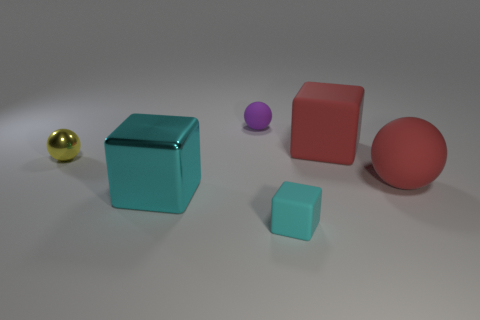Add 4 tiny purple matte objects. How many objects exist? 10 Add 1 big cubes. How many big cubes are left? 3 Add 5 brown metal objects. How many brown metal objects exist? 5 Subtract 0 yellow cylinders. How many objects are left? 6 Subtract all tiny gray matte cubes. Subtract all red blocks. How many objects are left? 5 